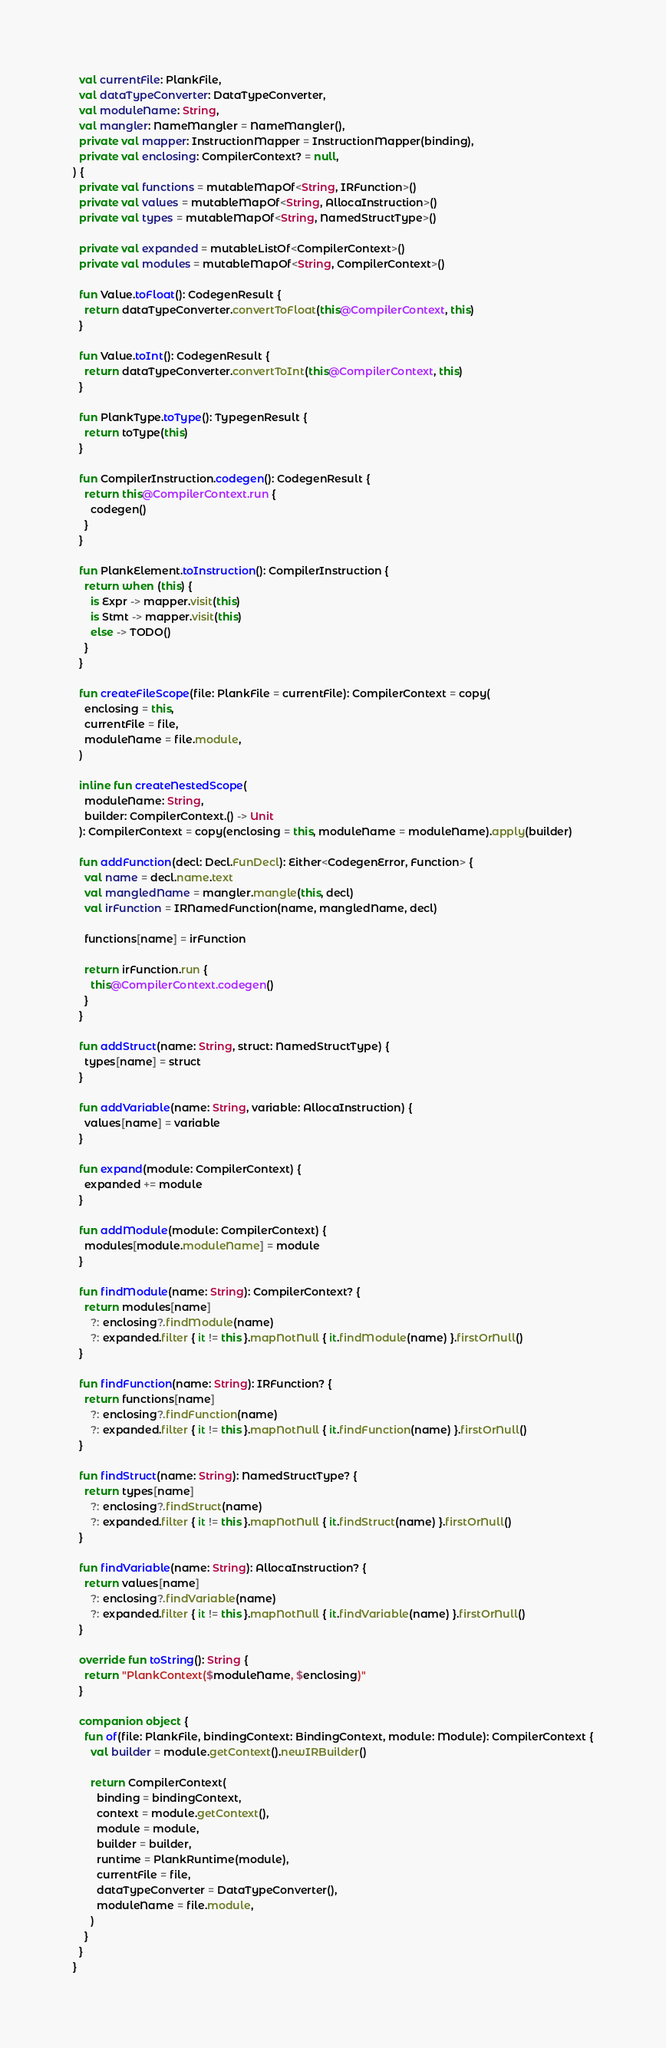Convert code to text. <code><loc_0><loc_0><loc_500><loc_500><_Kotlin_>  val currentFile: PlankFile,
  val dataTypeConverter: DataTypeConverter,
  val moduleName: String,
  val mangler: NameMangler = NameMangler(),
  private val mapper: InstructionMapper = InstructionMapper(binding),
  private val enclosing: CompilerContext? = null,
) {
  private val functions = mutableMapOf<String, IRFunction>()
  private val values = mutableMapOf<String, AllocaInstruction>()
  private val types = mutableMapOf<String, NamedStructType>()

  private val expanded = mutableListOf<CompilerContext>()
  private val modules = mutableMapOf<String, CompilerContext>()

  fun Value.toFloat(): CodegenResult {
    return dataTypeConverter.convertToFloat(this@CompilerContext, this)
  }

  fun Value.toInt(): CodegenResult {
    return dataTypeConverter.convertToInt(this@CompilerContext, this)
  }

  fun PlankType.toType(): TypegenResult {
    return toType(this)
  }

  fun CompilerInstruction.codegen(): CodegenResult {
    return this@CompilerContext.run {
      codegen()
    }
  }

  fun PlankElement.toInstruction(): CompilerInstruction {
    return when (this) {
      is Expr -> mapper.visit(this)
      is Stmt -> mapper.visit(this)
      else -> TODO()
    }
  }

  fun createFileScope(file: PlankFile = currentFile): CompilerContext = copy(
    enclosing = this,
    currentFile = file,
    moduleName = file.module,
  )

  inline fun createNestedScope(
    moduleName: String,
    builder: CompilerContext.() -> Unit
  ): CompilerContext = copy(enclosing = this, moduleName = moduleName).apply(builder)

  fun addFunction(decl: Decl.FunDecl): Either<CodegenError, Function> {
    val name = decl.name.text
    val mangledName = mangler.mangle(this, decl)
    val irFunction = IRNamedFunction(name, mangledName, decl)

    functions[name] = irFunction

    return irFunction.run {
      this@CompilerContext.codegen()
    }
  }

  fun addStruct(name: String, struct: NamedStructType) {
    types[name] = struct
  }

  fun addVariable(name: String, variable: AllocaInstruction) {
    values[name] = variable
  }

  fun expand(module: CompilerContext) {
    expanded += module
  }

  fun addModule(module: CompilerContext) {
    modules[module.moduleName] = module
  }

  fun findModule(name: String): CompilerContext? {
    return modules[name]
      ?: enclosing?.findModule(name)
      ?: expanded.filter { it != this }.mapNotNull { it.findModule(name) }.firstOrNull()
  }

  fun findFunction(name: String): IRFunction? {
    return functions[name]
      ?: enclosing?.findFunction(name)
      ?: expanded.filter { it != this }.mapNotNull { it.findFunction(name) }.firstOrNull()
  }

  fun findStruct(name: String): NamedStructType? {
    return types[name]
      ?: enclosing?.findStruct(name)
      ?: expanded.filter { it != this }.mapNotNull { it.findStruct(name) }.firstOrNull()
  }

  fun findVariable(name: String): AllocaInstruction? {
    return values[name]
      ?: enclosing?.findVariable(name)
      ?: expanded.filter { it != this }.mapNotNull { it.findVariable(name) }.firstOrNull()
  }

  override fun toString(): String {
    return "PlankContext($moduleName, $enclosing)"
  }

  companion object {
    fun of(file: PlankFile, bindingContext: BindingContext, module: Module): CompilerContext {
      val builder = module.getContext().newIRBuilder()

      return CompilerContext(
        binding = bindingContext,
        context = module.getContext(),
        module = module,
        builder = builder,
        runtime = PlankRuntime(module),
        currentFile = file,
        dataTypeConverter = DataTypeConverter(),
        moduleName = file.module,
      )
    }
  }
}
</code> 